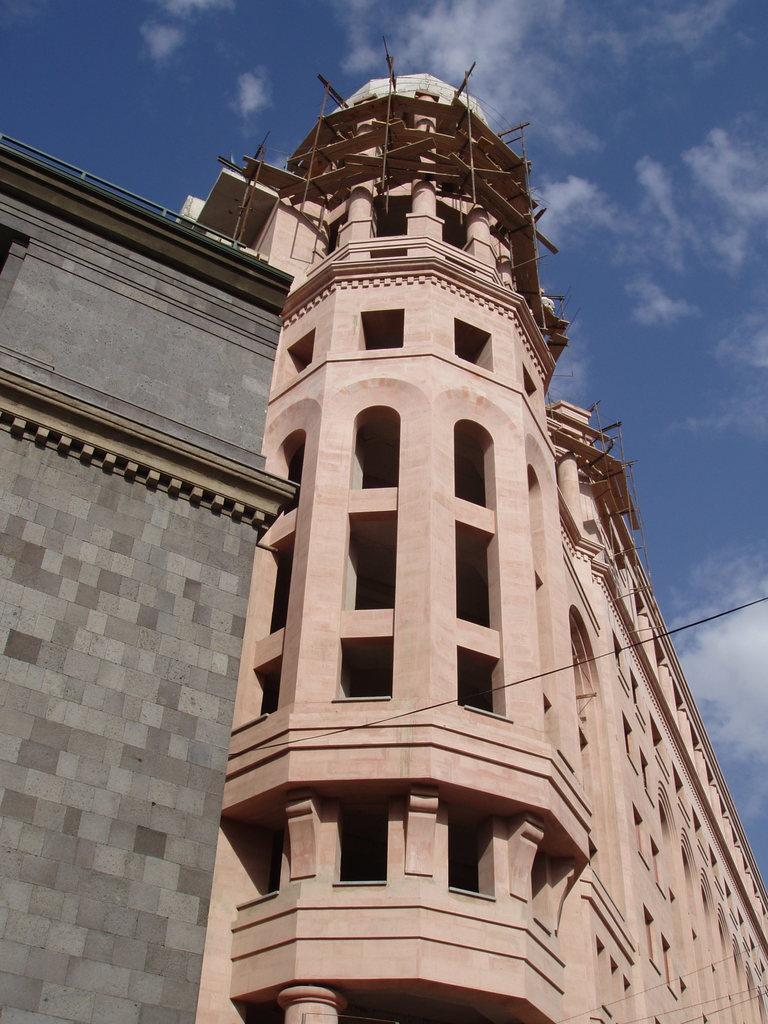How would you summarize this image in a sentence or two? In this image we can see the buildings with windows. We can also see some wires and the sky which looks cloudy. 